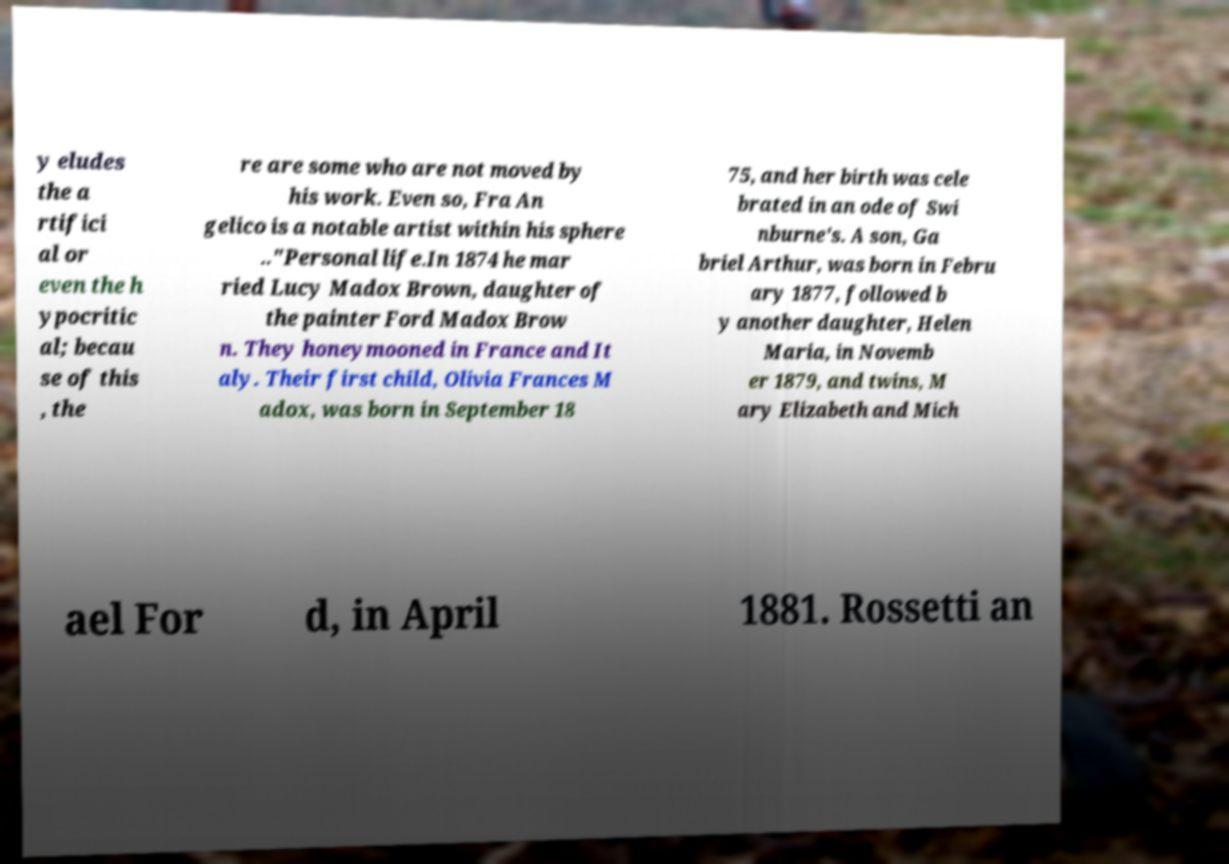There's text embedded in this image that I need extracted. Can you transcribe it verbatim? y eludes the a rtifici al or even the h ypocritic al; becau se of this , the re are some who are not moved by his work. Even so, Fra An gelico is a notable artist within his sphere .."Personal life.In 1874 he mar ried Lucy Madox Brown, daughter of the painter Ford Madox Brow n. They honeymooned in France and It aly. Their first child, Olivia Frances M adox, was born in September 18 75, and her birth was cele brated in an ode of Swi nburne's. A son, Ga briel Arthur, was born in Febru ary 1877, followed b y another daughter, Helen Maria, in Novemb er 1879, and twins, M ary Elizabeth and Mich ael For d, in April 1881. Rossetti an 